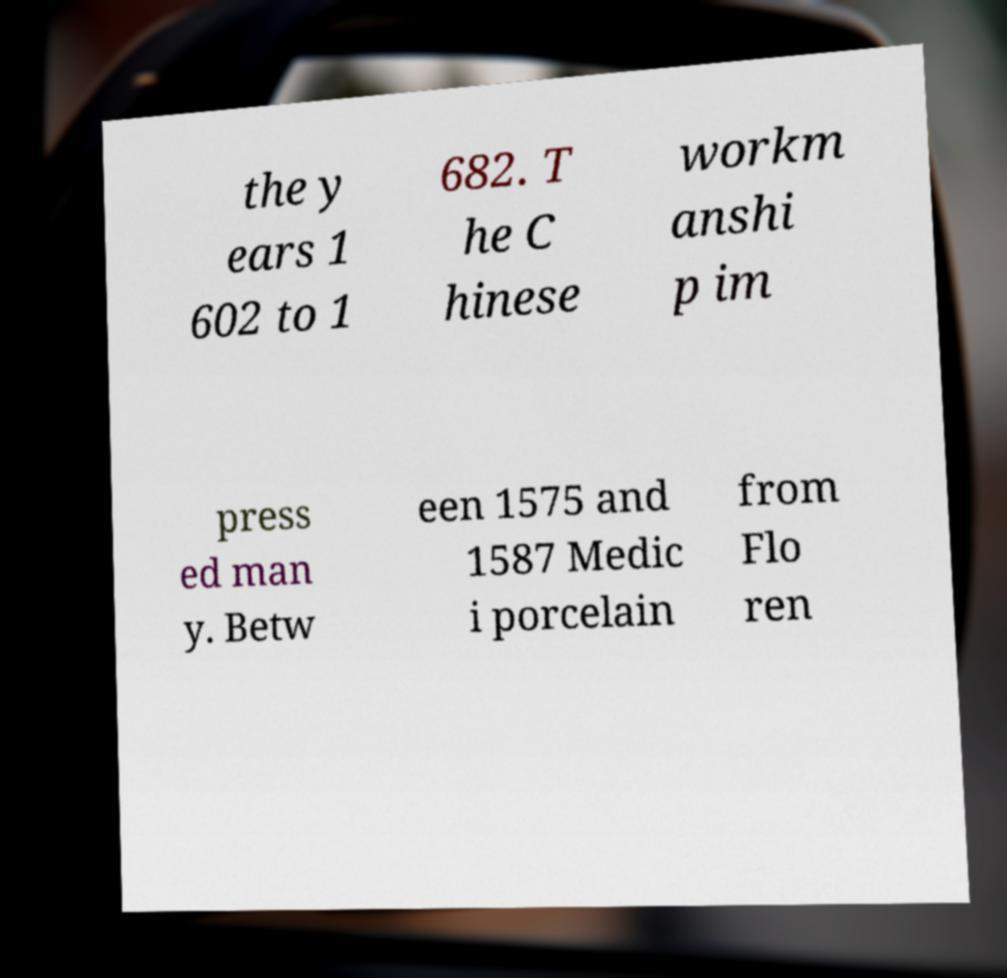Please read and relay the text visible in this image. What does it say? the y ears 1 602 to 1 682. T he C hinese workm anshi p im press ed man y. Betw een 1575 and 1587 Medic i porcelain from Flo ren 